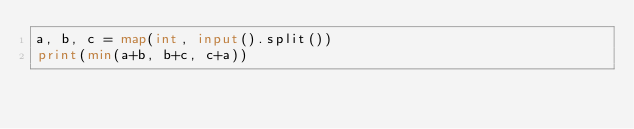<code> <loc_0><loc_0><loc_500><loc_500><_Python_>a, b, c = map(int, input().split())
print(min(a+b, b+c, c+a))</code> 